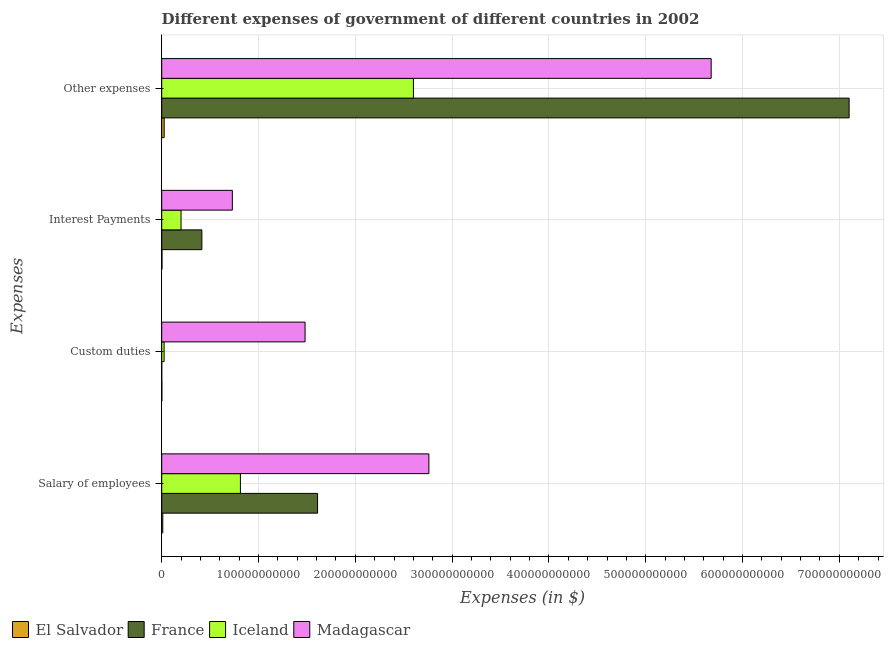How many different coloured bars are there?
Offer a terse response. 4. How many groups of bars are there?
Your answer should be very brief. 4. Are the number of bars per tick equal to the number of legend labels?
Your answer should be compact. Yes. Are the number of bars on each tick of the Y-axis equal?
Your answer should be very brief. Yes. How many bars are there on the 2nd tick from the top?
Give a very brief answer. 4. What is the label of the 4th group of bars from the top?
Give a very brief answer. Salary of employees. What is the amount spent on custom duties in El Salvador?
Offer a very short reply. 1.55e+08. Across all countries, what is the maximum amount spent on other expenses?
Provide a succinct answer. 7.10e+11. Across all countries, what is the minimum amount spent on interest payments?
Offer a terse response. 2.89e+08. In which country was the amount spent on salary of employees maximum?
Ensure brevity in your answer.  Madagascar. In which country was the amount spent on other expenses minimum?
Ensure brevity in your answer.  El Salvador. What is the total amount spent on other expenses in the graph?
Ensure brevity in your answer.  1.54e+12. What is the difference between the amount spent on interest payments in France and that in Iceland?
Your answer should be very brief. 2.15e+1. What is the difference between the amount spent on interest payments in France and the amount spent on custom duties in Madagascar?
Ensure brevity in your answer.  -1.07e+11. What is the average amount spent on other expenses per country?
Your response must be concise. 3.85e+11. What is the difference between the amount spent on salary of employees and amount spent on other expenses in El Salvador?
Provide a succinct answer. -1.45e+09. In how many countries, is the amount spent on custom duties greater than 340000000000 $?
Keep it short and to the point. 0. What is the ratio of the amount spent on custom duties in Madagascar to that in France?
Make the answer very short. 2.96e+04. Is the amount spent on custom duties in Madagascar less than that in France?
Offer a very short reply. No. Is the difference between the amount spent on custom duties in El Salvador and Iceland greater than the difference between the amount spent on interest payments in El Salvador and Iceland?
Make the answer very short. Yes. What is the difference between the highest and the second highest amount spent on interest payments?
Make the answer very short. 3.15e+1. What is the difference between the highest and the lowest amount spent on custom duties?
Make the answer very short. 1.48e+11. In how many countries, is the amount spent on other expenses greater than the average amount spent on other expenses taken over all countries?
Make the answer very short. 2. Is the sum of the amount spent on salary of employees in Madagascar and Iceland greater than the maximum amount spent on interest payments across all countries?
Provide a succinct answer. Yes. What does the 4th bar from the top in Interest Payments represents?
Offer a very short reply. El Salvador. Is it the case that in every country, the sum of the amount spent on salary of employees and amount spent on custom duties is greater than the amount spent on interest payments?
Keep it short and to the point. Yes. How many bars are there?
Your answer should be very brief. 16. Are all the bars in the graph horizontal?
Provide a succinct answer. Yes. How many countries are there in the graph?
Give a very brief answer. 4. What is the difference between two consecutive major ticks on the X-axis?
Give a very brief answer. 1.00e+11. How are the legend labels stacked?
Keep it short and to the point. Horizontal. What is the title of the graph?
Offer a terse response. Different expenses of government of different countries in 2002. Does "Puerto Rico" appear as one of the legend labels in the graph?
Keep it short and to the point. No. What is the label or title of the X-axis?
Offer a very short reply. Expenses (in $). What is the label or title of the Y-axis?
Keep it short and to the point. Expenses. What is the Expenses (in $) in El Salvador in Salary of employees?
Your answer should be compact. 1.11e+09. What is the Expenses (in $) of France in Salary of employees?
Make the answer very short. 1.61e+11. What is the Expenses (in $) in Iceland in Salary of employees?
Make the answer very short. 8.13e+1. What is the Expenses (in $) of Madagascar in Salary of employees?
Provide a short and direct response. 2.76e+11. What is the Expenses (in $) of El Salvador in Custom duties?
Offer a terse response. 1.55e+08. What is the Expenses (in $) of France in Custom duties?
Give a very brief answer. 5.00e+06. What is the Expenses (in $) in Iceland in Custom duties?
Make the answer very short. 2.47e+09. What is the Expenses (in $) of Madagascar in Custom duties?
Give a very brief answer. 1.48e+11. What is the Expenses (in $) in El Salvador in Interest Payments?
Offer a terse response. 2.89e+08. What is the Expenses (in $) of France in Interest Payments?
Offer a terse response. 4.15e+1. What is the Expenses (in $) of Iceland in Interest Payments?
Offer a very short reply. 2.00e+1. What is the Expenses (in $) in Madagascar in Interest Payments?
Ensure brevity in your answer.  7.30e+1. What is the Expenses (in $) in El Salvador in Other expenses?
Ensure brevity in your answer.  2.56e+09. What is the Expenses (in $) of France in Other expenses?
Provide a short and direct response. 7.10e+11. What is the Expenses (in $) in Iceland in Other expenses?
Provide a succinct answer. 2.60e+11. What is the Expenses (in $) in Madagascar in Other expenses?
Make the answer very short. 5.68e+11. Across all Expenses, what is the maximum Expenses (in $) of El Salvador?
Your answer should be very brief. 2.56e+09. Across all Expenses, what is the maximum Expenses (in $) of France?
Offer a very short reply. 7.10e+11. Across all Expenses, what is the maximum Expenses (in $) of Iceland?
Offer a terse response. 2.60e+11. Across all Expenses, what is the maximum Expenses (in $) in Madagascar?
Provide a short and direct response. 5.68e+11. Across all Expenses, what is the minimum Expenses (in $) of El Salvador?
Your response must be concise. 1.55e+08. Across all Expenses, what is the minimum Expenses (in $) in Iceland?
Keep it short and to the point. 2.47e+09. Across all Expenses, what is the minimum Expenses (in $) of Madagascar?
Your response must be concise. 7.30e+1. What is the total Expenses (in $) of El Salvador in the graph?
Offer a terse response. 4.11e+09. What is the total Expenses (in $) of France in the graph?
Your answer should be very brief. 9.13e+11. What is the total Expenses (in $) of Iceland in the graph?
Make the answer very short. 3.64e+11. What is the total Expenses (in $) of Madagascar in the graph?
Make the answer very short. 1.06e+12. What is the difference between the Expenses (in $) in El Salvador in Salary of employees and that in Custom duties?
Keep it short and to the point. 9.52e+08. What is the difference between the Expenses (in $) of France in Salary of employees and that in Custom duties?
Give a very brief answer. 1.61e+11. What is the difference between the Expenses (in $) of Iceland in Salary of employees and that in Custom duties?
Offer a very short reply. 7.88e+1. What is the difference between the Expenses (in $) in Madagascar in Salary of employees and that in Custom duties?
Offer a very short reply. 1.28e+11. What is the difference between the Expenses (in $) in El Salvador in Salary of employees and that in Interest Payments?
Your response must be concise. 8.18e+08. What is the difference between the Expenses (in $) of France in Salary of employees and that in Interest Payments?
Provide a short and direct response. 1.20e+11. What is the difference between the Expenses (in $) of Iceland in Salary of employees and that in Interest Payments?
Keep it short and to the point. 6.13e+1. What is the difference between the Expenses (in $) in Madagascar in Salary of employees and that in Interest Payments?
Provide a succinct answer. 2.03e+11. What is the difference between the Expenses (in $) in El Salvador in Salary of employees and that in Other expenses?
Provide a short and direct response. -1.45e+09. What is the difference between the Expenses (in $) in France in Salary of employees and that in Other expenses?
Provide a succinct answer. -5.49e+11. What is the difference between the Expenses (in $) of Iceland in Salary of employees and that in Other expenses?
Provide a short and direct response. -1.79e+11. What is the difference between the Expenses (in $) of Madagascar in Salary of employees and that in Other expenses?
Your response must be concise. -2.92e+11. What is the difference between the Expenses (in $) in El Salvador in Custom duties and that in Interest Payments?
Provide a short and direct response. -1.34e+08. What is the difference between the Expenses (in $) in France in Custom duties and that in Interest Payments?
Your response must be concise. -4.15e+1. What is the difference between the Expenses (in $) of Iceland in Custom duties and that in Interest Payments?
Offer a terse response. -1.75e+1. What is the difference between the Expenses (in $) of Madagascar in Custom duties and that in Interest Payments?
Keep it short and to the point. 7.51e+1. What is the difference between the Expenses (in $) in El Salvador in Custom duties and that in Other expenses?
Offer a terse response. -2.41e+09. What is the difference between the Expenses (in $) in France in Custom duties and that in Other expenses?
Your response must be concise. -7.10e+11. What is the difference between the Expenses (in $) in Iceland in Custom duties and that in Other expenses?
Your response must be concise. -2.58e+11. What is the difference between the Expenses (in $) of Madagascar in Custom duties and that in Other expenses?
Your answer should be compact. -4.20e+11. What is the difference between the Expenses (in $) in El Salvador in Interest Payments and that in Other expenses?
Offer a terse response. -2.27e+09. What is the difference between the Expenses (in $) in France in Interest Payments and that in Other expenses?
Make the answer very short. -6.69e+11. What is the difference between the Expenses (in $) of Iceland in Interest Payments and that in Other expenses?
Your answer should be very brief. -2.40e+11. What is the difference between the Expenses (in $) of Madagascar in Interest Payments and that in Other expenses?
Offer a terse response. -4.95e+11. What is the difference between the Expenses (in $) in El Salvador in Salary of employees and the Expenses (in $) in France in Custom duties?
Provide a short and direct response. 1.10e+09. What is the difference between the Expenses (in $) of El Salvador in Salary of employees and the Expenses (in $) of Iceland in Custom duties?
Your answer should be compact. -1.37e+09. What is the difference between the Expenses (in $) in El Salvador in Salary of employees and the Expenses (in $) in Madagascar in Custom duties?
Provide a succinct answer. -1.47e+11. What is the difference between the Expenses (in $) of France in Salary of employees and the Expenses (in $) of Iceland in Custom duties?
Offer a very short reply. 1.59e+11. What is the difference between the Expenses (in $) in France in Salary of employees and the Expenses (in $) in Madagascar in Custom duties?
Make the answer very short. 1.29e+1. What is the difference between the Expenses (in $) in Iceland in Salary of employees and the Expenses (in $) in Madagascar in Custom duties?
Make the answer very short. -6.68e+1. What is the difference between the Expenses (in $) in El Salvador in Salary of employees and the Expenses (in $) in France in Interest Payments?
Offer a terse response. -4.04e+1. What is the difference between the Expenses (in $) in El Salvador in Salary of employees and the Expenses (in $) in Iceland in Interest Payments?
Give a very brief answer. -1.89e+1. What is the difference between the Expenses (in $) of El Salvador in Salary of employees and the Expenses (in $) of Madagascar in Interest Payments?
Keep it short and to the point. -7.19e+1. What is the difference between the Expenses (in $) in France in Salary of employees and the Expenses (in $) in Iceland in Interest Payments?
Offer a very short reply. 1.41e+11. What is the difference between the Expenses (in $) in France in Salary of employees and the Expenses (in $) in Madagascar in Interest Payments?
Make the answer very short. 8.80e+1. What is the difference between the Expenses (in $) in Iceland in Salary of employees and the Expenses (in $) in Madagascar in Interest Payments?
Offer a terse response. 8.35e+09. What is the difference between the Expenses (in $) in El Salvador in Salary of employees and the Expenses (in $) in France in Other expenses?
Provide a short and direct response. -7.09e+11. What is the difference between the Expenses (in $) of El Salvador in Salary of employees and the Expenses (in $) of Iceland in Other expenses?
Make the answer very short. -2.59e+11. What is the difference between the Expenses (in $) in El Salvador in Salary of employees and the Expenses (in $) in Madagascar in Other expenses?
Offer a very short reply. -5.66e+11. What is the difference between the Expenses (in $) of France in Salary of employees and the Expenses (in $) of Iceland in Other expenses?
Provide a succinct answer. -9.90e+1. What is the difference between the Expenses (in $) of France in Salary of employees and the Expenses (in $) of Madagascar in Other expenses?
Offer a very short reply. -4.07e+11. What is the difference between the Expenses (in $) in Iceland in Salary of employees and the Expenses (in $) in Madagascar in Other expenses?
Make the answer very short. -4.86e+11. What is the difference between the Expenses (in $) of El Salvador in Custom duties and the Expenses (in $) of France in Interest Payments?
Keep it short and to the point. -4.13e+1. What is the difference between the Expenses (in $) in El Salvador in Custom duties and the Expenses (in $) in Iceland in Interest Payments?
Provide a short and direct response. -1.98e+1. What is the difference between the Expenses (in $) in El Salvador in Custom duties and the Expenses (in $) in Madagascar in Interest Payments?
Your answer should be very brief. -7.28e+1. What is the difference between the Expenses (in $) in France in Custom duties and the Expenses (in $) in Iceland in Interest Payments?
Ensure brevity in your answer.  -2.00e+1. What is the difference between the Expenses (in $) in France in Custom duties and the Expenses (in $) in Madagascar in Interest Payments?
Ensure brevity in your answer.  -7.30e+1. What is the difference between the Expenses (in $) of Iceland in Custom duties and the Expenses (in $) of Madagascar in Interest Payments?
Ensure brevity in your answer.  -7.05e+1. What is the difference between the Expenses (in $) in El Salvador in Custom duties and the Expenses (in $) in France in Other expenses?
Your answer should be very brief. -7.10e+11. What is the difference between the Expenses (in $) of El Salvador in Custom duties and the Expenses (in $) of Iceland in Other expenses?
Provide a short and direct response. -2.60e+11. What is the difference between the Expenses (in $) in El Salvador in Custom duties and the Expenses (in $) in Madagascar in Other expenses?
Make the answer very short. -5.67e+11. What is the difference between the Expenses (in $) in France in Custom duties and the Expenses (in $) in Iceland in Other expenses?
Your response must be concise. -2.60e+11. What is the difference between the Expenses (in $) in France in Custom duties and the Expenses (in $) in Madagascar in Other expenses?
Your answer should be compact. -5.68e+11. What is the difference between the Expenses (in $) of Iceland in Custom duties and the Expenses (in $) of Madagascar in Other expenses?
Provide a succinct answer. -5.65e+11. What is the difference between the Expenses (in $) in El Salvador in Interest Payments and the Expenses (in $) in France in Other expenses?
Offer a very short reply. -7.10e+11. What is the difference between the Expenses (in $) of El Salvador in Interest Payments and the Expenses (in $) of Iceland in Other expenses?
Provide a succinct answer. -2.60e+11. What is the difference between the Expenses (in $) in El Salvador in Interest Payments and the Expenses (in $) in Madagascar in Other expenses?
Your answer should be very brief. -5.67e+11. What is the difference between the Expenses (in $) in France in Interest Payments and the Expenses (in $) in Iceland in Other expenses?
Keep it short and to the point. -2.19e+11. What is the difference between the Expenses (in $) in France in Interest Payments and the Expenses (in $) in Madagascar in Other expenses?
Your response must be concise. -5.26e+11. What is the difference between the Expenses (in $) of Iceland in Interest Payments and the Expenses (in $) of Madagascar in Other expenses?
Offer a terse response. -5.48e+11. What is the average Expenses (in $) in El Salvador per Expenses?
Offer a terse response. 1.03e+09. What is the average Expenses (in $) of France per Expenses?
Offer a terse response. 2.28e+11. What is the average Expenses (in $) in Iceland per Expenses?
Your answer should be compact. 9.09e+1. What is the average Expenses (in $) of Madagascar per Expenses?
Your answer should be very brief. 2.66e+11. What is the difference between the Expenses (in $) in El Salvador and Expenses (in $) in France in Salary of employees?
Keep it short and to the point. -1.60e+11. What is the difference between the Expenses (in $) of El Salvador and Expenses (in $) of Iceland in Salary of employees?
Your response must be concise. -8.02e+1. What is the difference between the Expenses (in $) in El Salvador and Expenses (in $) in Madagascar in Salary of employees?
Give a very brief answer. -2.75e+11. What is the difference between the Expenses (in $) in France and Expenses (in $) in Iceland in Salary of employees?
Give a very brief answer. 7.97e+1. What is the difference between the Expenses (in $) of France and Expenses (in $) of Madagascar in Salary of employees?
Keep it short and to the point. -1.15e+11. What is the difference between the Expenses (in $) of Iceland and Expenses (in $) of Madagascar in Salary of employees?
Ensure brevity in your answer.  -1.95e+11. What is the difference between the Expenses (in $) of El Salvador and Expenses (in $) of France in Custom duties?
Your answer should be very brief. 1.50e+08. What is the difference between the Expenses (in $) of El Salvador and Expenses (in $) of Iceland in Custom duties?
Give a very brief answer. -2.32e+09. What is the difference between the Expenses (in $) of El Salvador and Expenses (in $) of Madagascar in Custom duties?
Your answer should be very brief. -1.48e+11. What is the difference between the Expenses (in $) of France and Expenses (in $) of Iceland in Custom duties?
Make the answer very short. -2.47e+09. What is the difference between the Expenses (in $) in France and Expenses (in $) in Madagascar in Custom duties?
Your response must be concise. -1.48e+11. What is the difference between the Expenses (in $) in Iceland and Expenses (in $) in Madagascar in Custom duties?
Your answer should be compact. -1.46e+11. What is the difference between the Expenses (in $) of El Salvador and Expenses (in $) of France in Interest Payments?
Give a very brief answer. -4.12e+1. What is the difference between the Expenses (in $) in El Salvador and Expenses (in $) in Iceland in Interest Payments?
Keep it short and to the point. -1.97e+1. What is the difference between the Expenses (in $) of El Salvador and Expenses (in $) of Madagascar in Interest Payments?
Make the answer very short. -7.27e+1. What is the difference between the Expenses (in $) in France and Expenses (in $) in Iceland in Interest Payments?
Offer a very short reply. 2.15e+1. What is the difference between the Expenses (in $) of France and Expenses (in $) of Madagascar in Interest Payments?
Give a very brief answer. -3.15e+1. What is the difference between the Expenses (in $) of Iceland and Expenses (in $) of Madagascar in Interest Payments?
Provide a succinct answer. -5.30e+1. What is the difference between the Expenses (in $) of El Salvador and Expenses (in $) of France in Other expenses?
Your answer should be very brief. -7.08e+11. What is the difference between the Expenses (in $) of El Salvador and Expenses (in $) of Iceland in Other expenses?
Provide a succinct answer. -2.57e+11. What is the difference between the Expenses (in $) in El Salvador and Expenses (in $) in Madagascar in Other expenses?
Offer a terse response. -5.65e+11. What is the difference between the Expenses (in $) in France and Expenses (in $) in Iceland in Other expenses?
Ensure brevity in your answer.  4.50e+11. What is the difference between the Expenses (in $) in France and Expenses (in $) in Madagascar in Other expenses?
Offer a terse response. 1.43e+11. What is the difference between the Expenses (in $) in Iceland and Expenses (in $) in Madagascar in Other expenses?
Provide a succinct answer. -3.08e+11. What is the ratio of the Expenses (in $) in El Salvador in Salary of employees to that in Custom duties?
Offer a very short reply. 7.15. What is the ratio of the Expenses (in $) of France in Salary of employees to that in Custom duties?
Your answer should be compact. 3.22e+04. What is the ratio of the Expenses (in $) in Iceland in Salary of employees to that in Custom duties?
Offer a very short reply. 32.86. What is the ratio of the Expenses (in $) in Madagascar in Salary of employees to that in Custom duties?
Keep it short and to the point. 1.86. What is the ratio of the Expenses (in $) in El Salvador in Salary of employees to that in Interest Payments?
Provide a succinct answer. 3.83. What is the ratio of the Expenses (in $) in France in Salary of employees to that in Interest Payments?
Make the answer very short. 3.88. What is the ratio of the Expenses (in $) of Iceland in Salary of employees to that in Interest Payments?
Provide a succinct answer. 4.07. What is the ratio of the Expenses (in $) of Madagascar in Salary of employees to that in Interest Payments?
Your answer should be very brief. 3.78. What is the ratio of the Expenses (in $) in El Salvador in Salary of employees to that in Other expenses?
Ensure brevity in your answer.  0.43. What is the ratio of the Expenses (in $) of France in Salary of employees to that in Other expenses?
Ensure brevity in your answer.  0.23. What is the ratio of the Expenses (in $) in Iceland in Salary of employees to that in Other expenses?
Ensure brevity in your answer.  0.31. What is the ratio of the Expenses (in $) of Madagascar in Salary of employees to that in Other expenses?
Your response must be concise. 0.49. What is the ratio of the Expenses (in $) in El Salvador in Custom duties to that in Interest Payments?
Provide a short and direct response. 0.54. What is the ratio of the Expenses (in $) in Iceland in Custom duties to that in Interest Payments?
Provide a short and direct response. 0.12. What is the ratio of the Expenses (in $) of Madagascar in Custom duties to that in Interest Payments?
Provide a succinct answer. 2.03. What is the ratio of the Expenses (in $) of El Salvador in Custom duties to that in Other expenses?
Provide a succinct answer. 0.06. What is the ratio of the Expenses (in $) in France in Custom duties to that in Other expenses?
Give a very brief answer. 0. What is the ratio of the Expenses (in $) in Iceland in Custom duties to that in Other expenses?
Offer a very short reply. 0.01. What is the ratio of the Expenses (in $) in Madagascar in Custom duties to that in Other expenses?
Give a very brief answer. 0.26. What is the ratio of the Expenses (in $) of El Salvador in Interest Payments to that in Other expenses?
Make the answer very short. 0.11. What is the ratio of the Expenses (in $) in France in Interest Payments to that in Other expenses?
Your response must be concise. 0.06. What is the ratio of the Expenses (in $) in Iceland in Interest Payments to that in Other expenses?
Keep it short and to the point. 0.08. What is the ratio of the Expenses (in $) of Madagascar in Interest Payments to that in Other expenses?
Your answer should be compact. 0.13. What is the difference between the highest and the second highest Expenses (in $) in El Salvador?
Keep it short and to the point. 1.45e+09. What is the difference between the highest and the second highest Expenses (in $) of France?
Ensure brevity in your answer.  5.49e+11. What is the difference between the highest and the second highest Expenses (in $) in Iceland?
Ensure brevity in your answer.  1.79e+11. What is the difference between the highest and the second highest Expenses (in $) in Madagascar?
Your answer should be compact. 2.92e+11. What is the difference between the highest and the lowest Expenses (in $) of El Salvador?
Give a very brief answer. 2.41e+09. What is the difference between the highest and the lowest Expenses (in $) of France?
Keep it short and to the point. 7.10e+11. What is the difference between the highest and the lowest Expenses (in $) of Iceland?
Make the answer very short. 2.58e+11. What is the difference between the highest and the lowest Expenses (in $) in Madagascar?
Provide a succinct answer. 4.95e+11. 